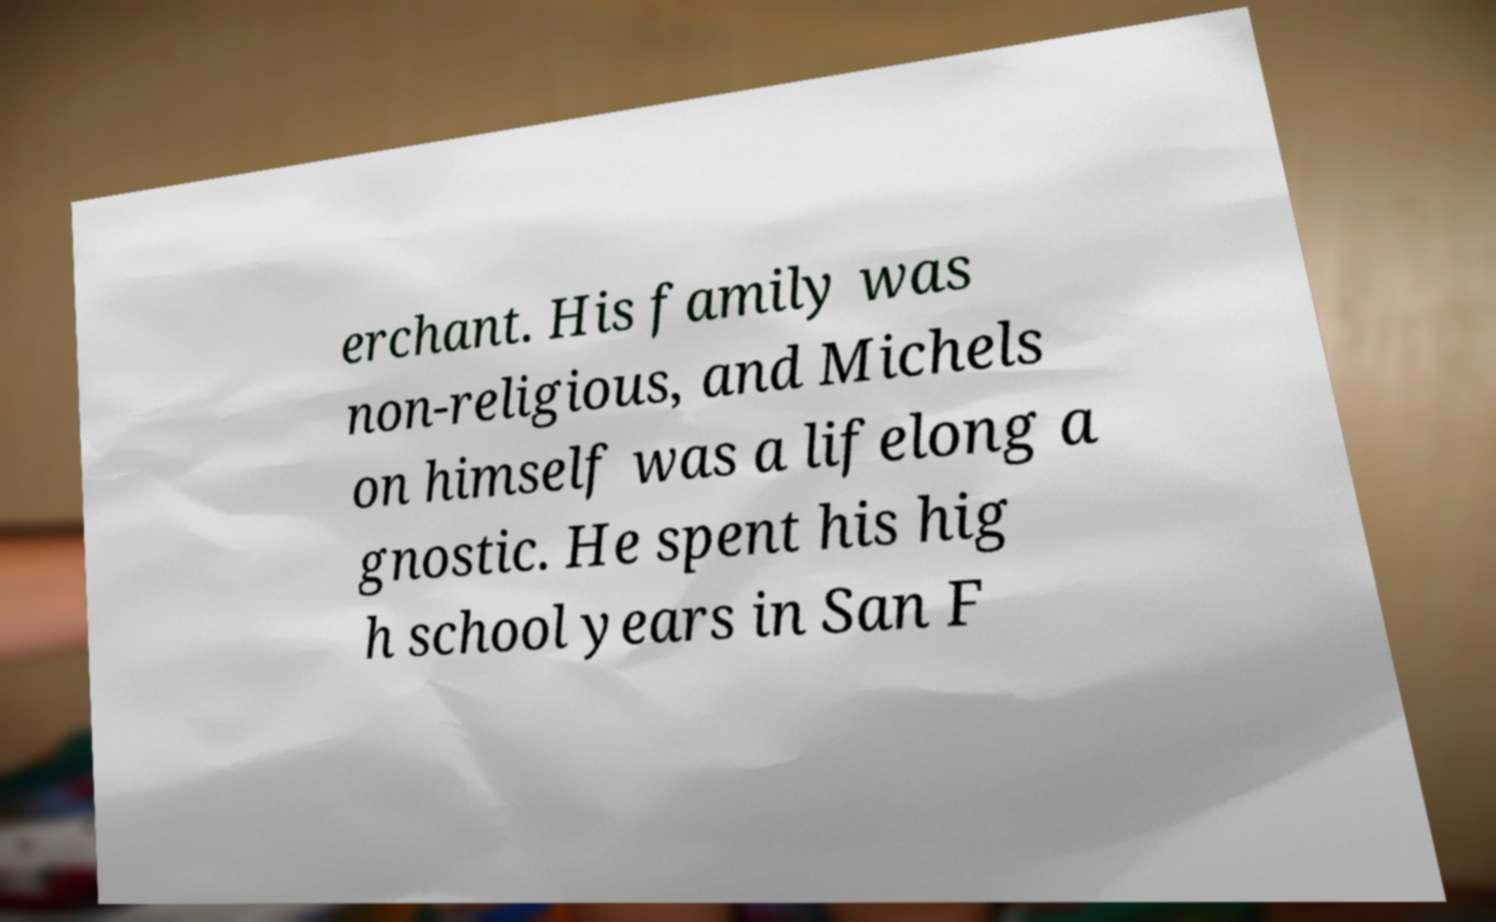Can you accurately transcribe the text from the provided image for me? erchant. His family was non-religious, and Michels on himself was a lifelong a gnostic. He spent his hig h school years in San F 